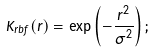Convert formula to latex. <formula><loc_0><loc_0><loc_500><loc_500>K _ { r b f } ( r ) = \exp \left ( - \frac { r ^ { 2 } } { \sigma ^ { 2 } } \right ) ;</formula> 